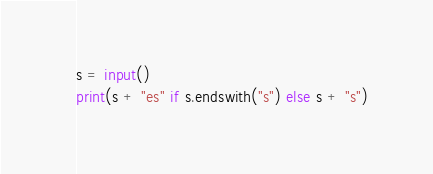<code> <loc_0><loc_0><loc_500><loc_500><_Python_>s = input()
print(s + "es" if s.endswith("s") else s + "s")</code> 